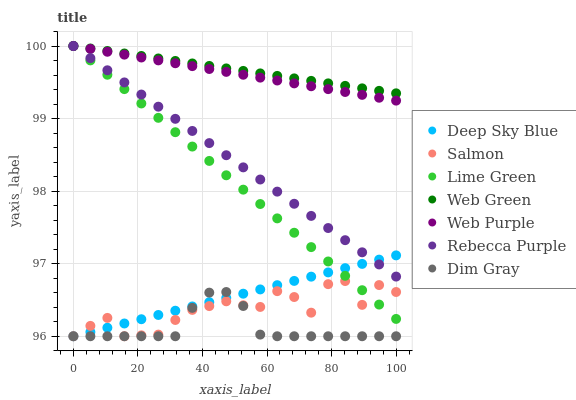Does Dim Gray have the minimum area under the curve?
Answer yes or no. Yes. Does Web Green have the maximum area under the curve?
Answer yes or no. Yes. Does Salmon have the minimum area under the curve?
Answer yes or no. No. Does Salmon have the maximum area under the curve?
Answer yes or no. No. Is Deep Sky Blue the smoothest?
Answer yes or no. Yes. Is Salmon the roughest?
Answer yes or no. Yes. Is Web Green the smoothest?
Answer yes or no. No. Is Web Green the roughest?
Answer yes or no. No. Does Dim Gray have the lowest value?
Answer yes or no. Yes. Does Web Green have the lowest value?
Answer yes or no. No. Does Lime Green have the highest value?
Answer yes or no. Yes. Does Salmon have the highest value?
Answer yes or no. No. Is Salmon less than Web Green?
Answer yes or no. Yes. Is Lime Green greater than Dim Gray?
Answer yes or no. Yes. Does Web Green intersect Rebecca Purple?
Answer yes or no. Yes. Is Web Green less than Rebecca Purple?
Answer yes or no. No. Is Web Green greater than Rebecca Purple?
Answer yes or no. No. Does Salmon intersect Web Green?
Answer yes or no. No. 